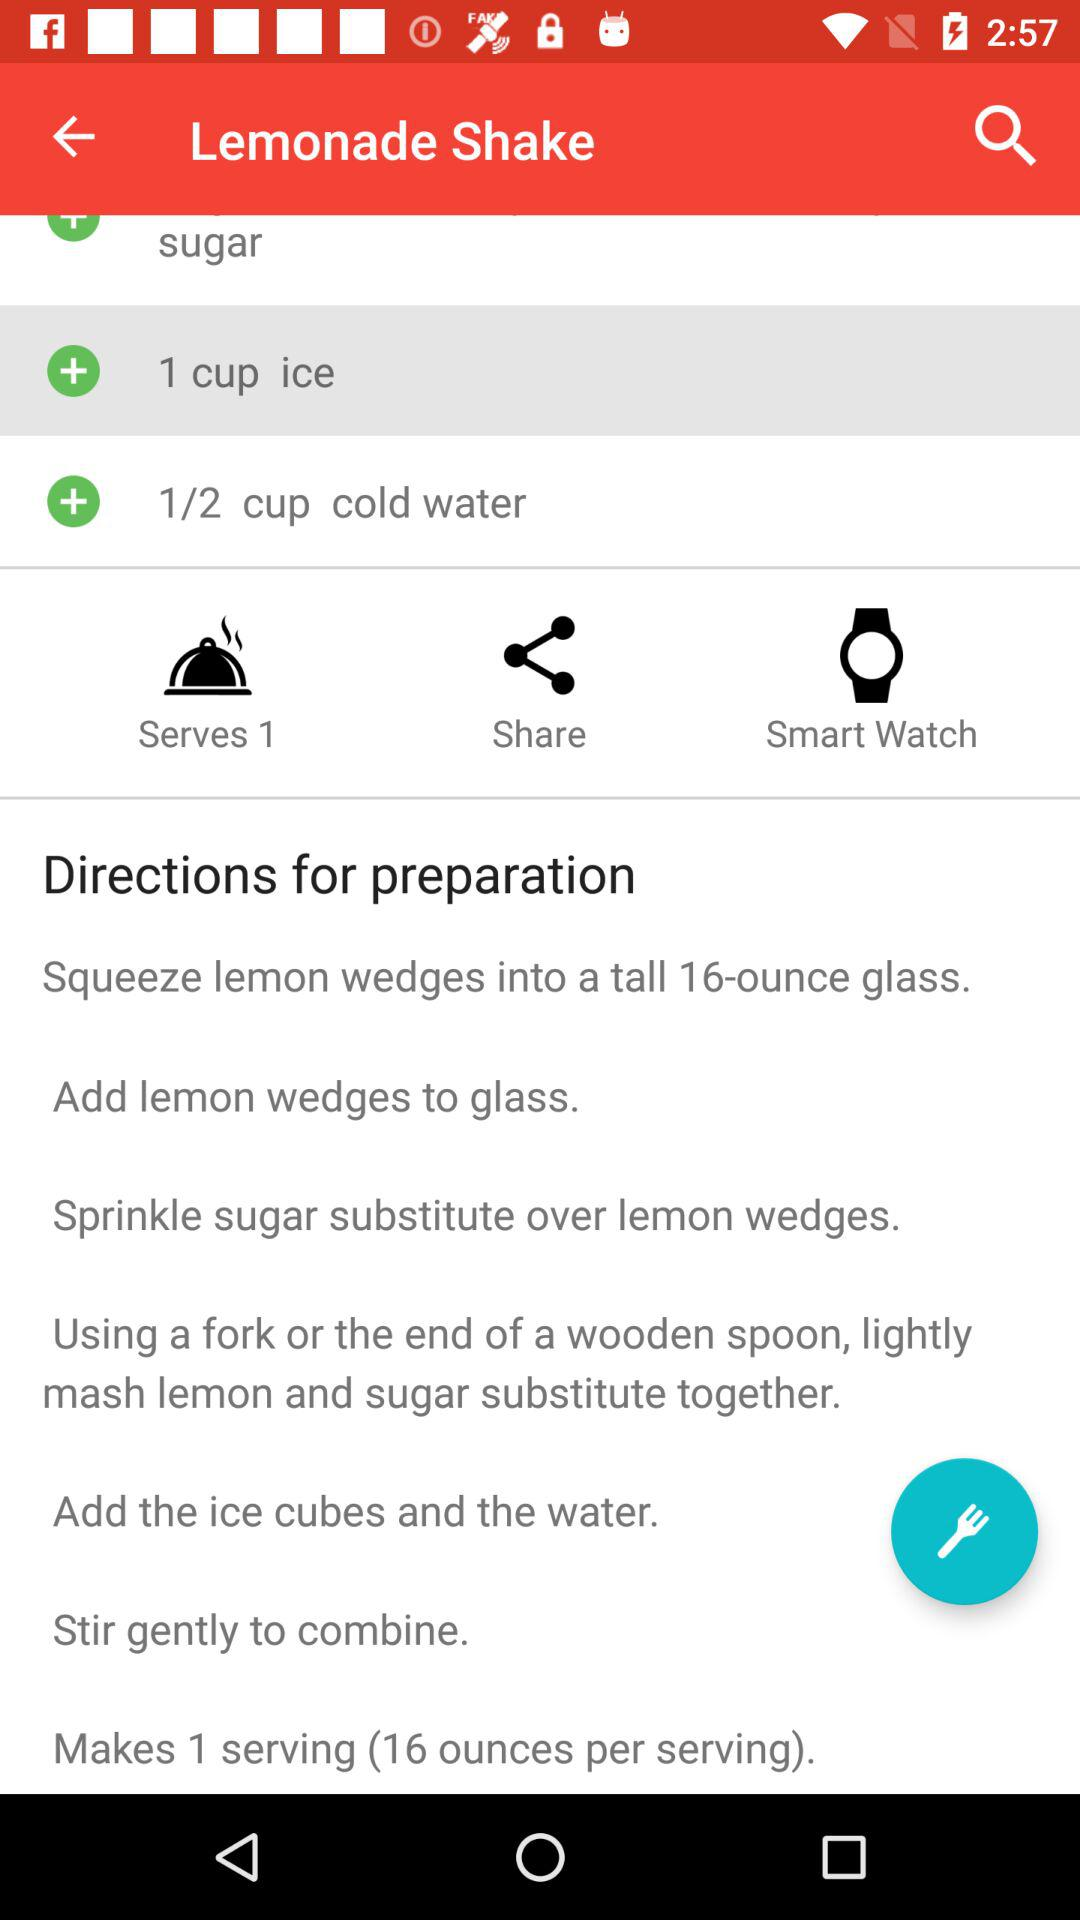What is the amount of ice in the "Lemonade Shake"? The amount of ice in the "Lemonade Shake" is 1 cup. 